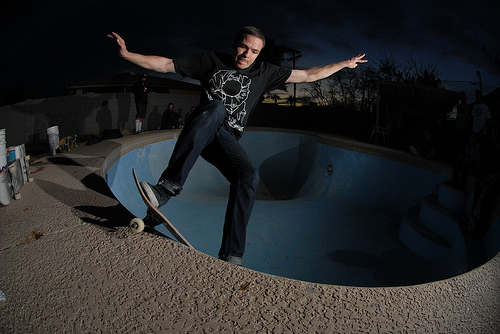What is the person doing in the image? The person is skateboarding, specifically performing a trick inside what appears to be an empty swimming pool, a popular location for skateboarders looking for smooth surfaces and curved walls to ride on. Does this activity have a specific name? Yes, skateboarding in empty pools is often referred to as 'pool skating' or 'bowl skating.' Skaters use the curves of the pool to gain momentum and perform various tricks. 